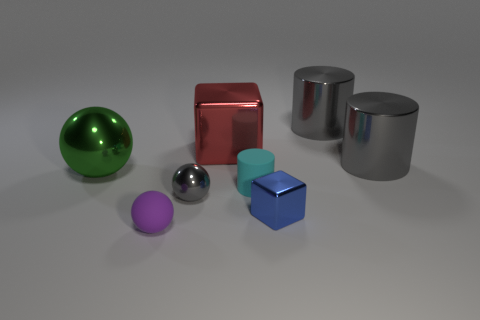Add 2 blue metal objects. How many objects exist? 10 Subtract all cylinders. How many objects are left? 5 Add 1 large red matte cylinders. How many large red matte cylinders exist? 1 Subtract 2 gray cylinders. How many objects are left? 6 Subtract all gray shiny things. Subtract all purple balls. How many objects are left? 4 Add 5 blue metallic things. How many blue metallic things are left? 6 